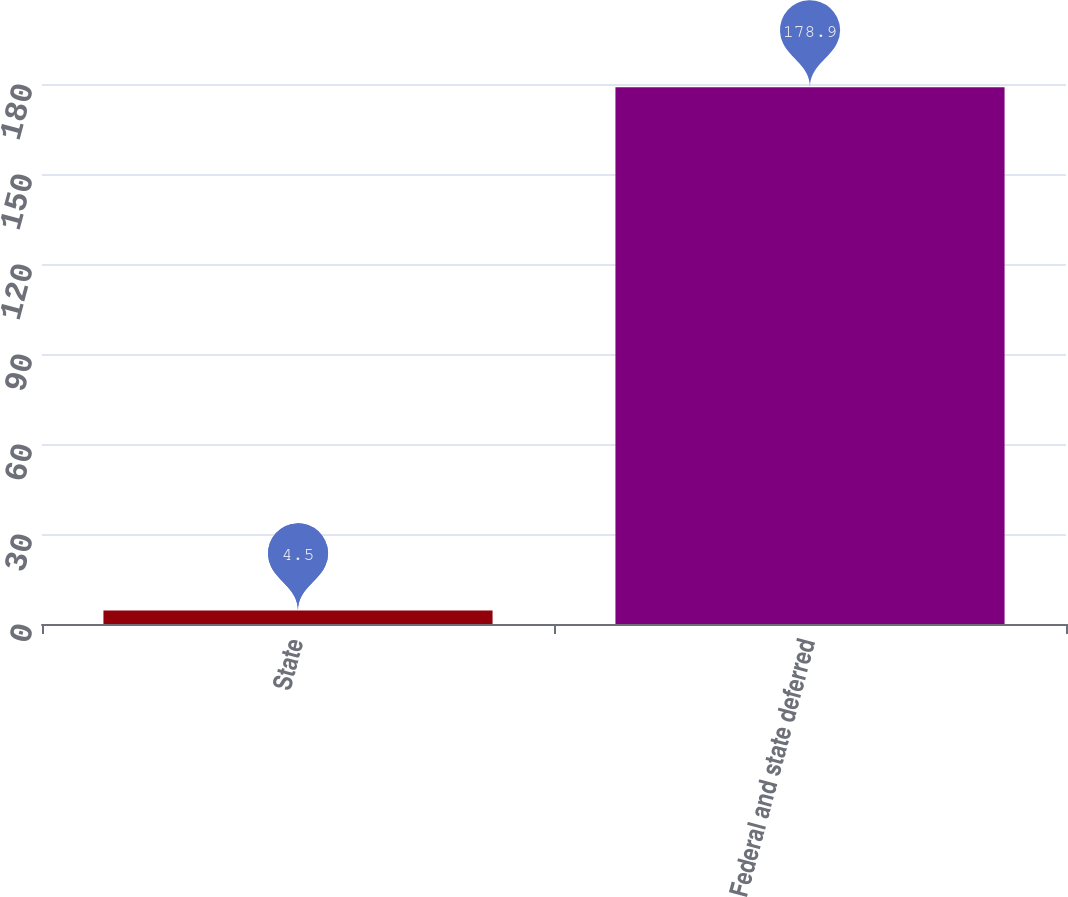<chart> <loc_0><loc_0><loc_500><loc_500><bar_chart><fcel>State<fcel>Federal and state deferred<nl><fcel>4.5<fcel>178.9<nl></chart> 